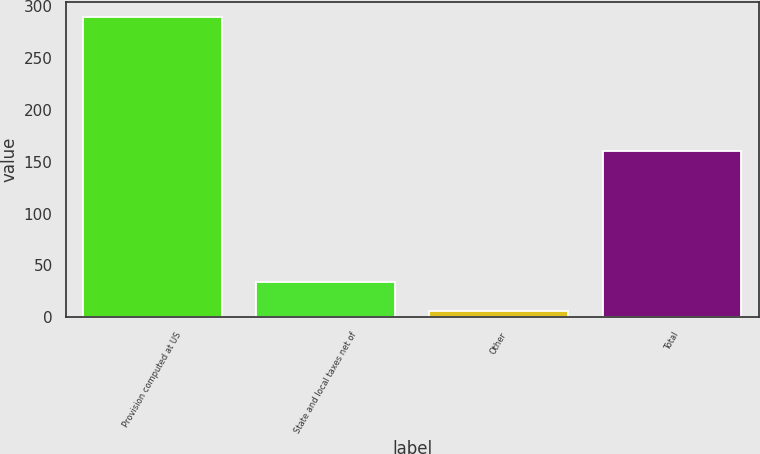Convert chart to OTSL. <chart><loc_0><loc_0><loc_500><loc_500><bar_chart><fcel>Provision computed at US<fcel>State and local taxes net of<fcel>Other<fcel>Total<nl><fcel>290<fcel>34.13<fcel>5.7<fcel>160<nl></chart> 